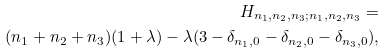Convert formula to latex. <formula><loc_0><loc_0><loc_500><loc_500>H _ { n _ { 1 } , n _ { 2 } , n _ { 3 } ; n _ { 1 } , n _ { 2 } , n _ { 3 } } = \\ ( n _ { 1 } + n _ { 2 } + n _ { 3 } ) ( 1 + \lambda ) - \lambda ( 3 - \delta _ { n _ { 1 } , 0 } - \delta _ { n _ { 2 } , 0 } - \delta _ { n _ { 3 } , 0 } ) ,</formula> 